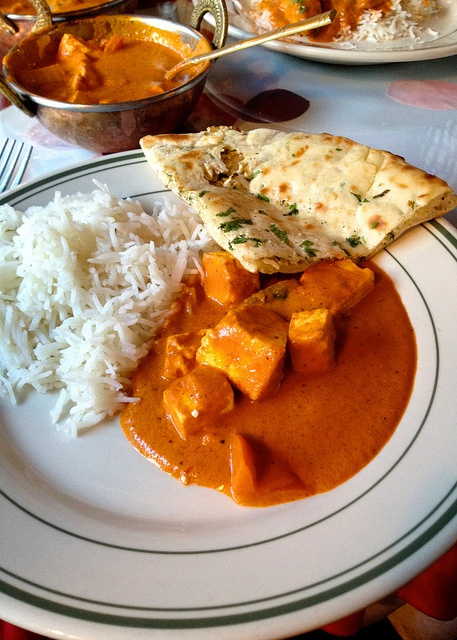Describe the objects in this image and their specific colors. I can see dining table in lightgray, darkgray, maroon, and brown tones, pizza in maroon, khaki, olive, tan, and beige tones, bowl in maroon, red, black, and orange tones, spoon in maroon, ivory, olive, and tan tones, and bowl in maroon, ivory, olive, khaki, and tan tones in this image. 